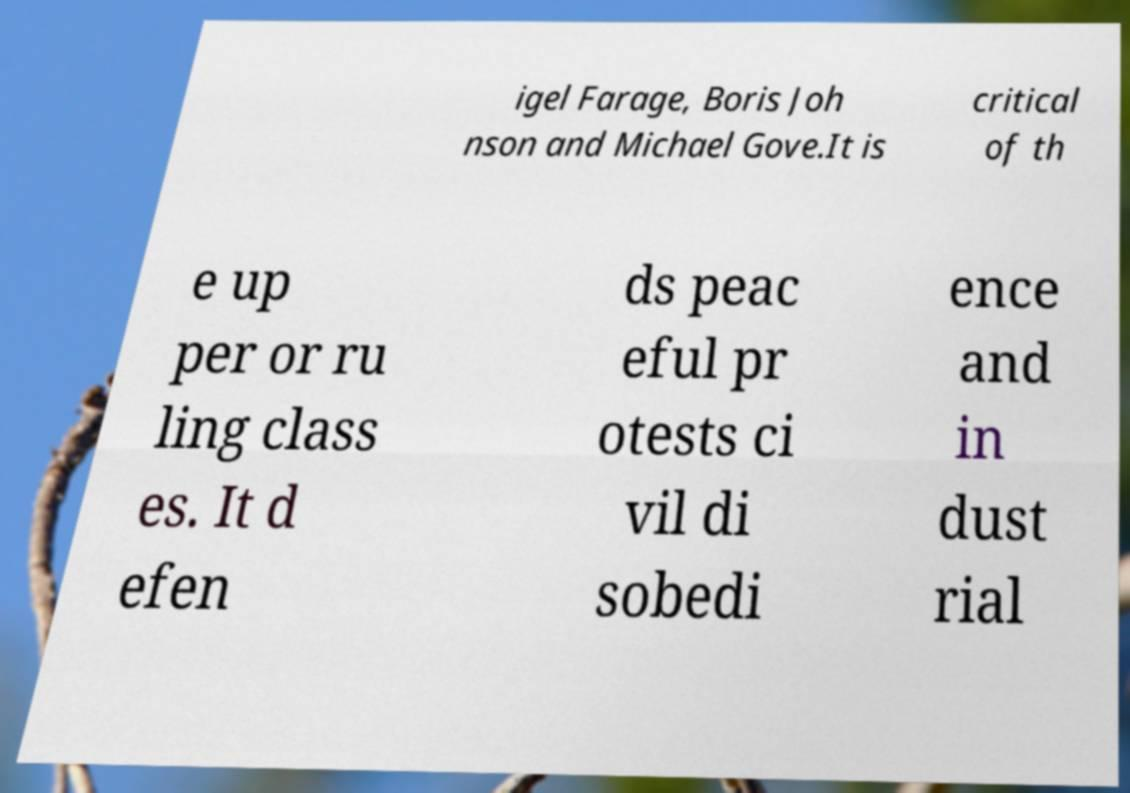Please identify and transcribe the text found in this image. igel Farage, Boris Joh nson and Michael Gove.It is critical of th e up per or ru ling class es. It d efen ds peac eful pr otests ci vil di sobedi ence and in dust rial 